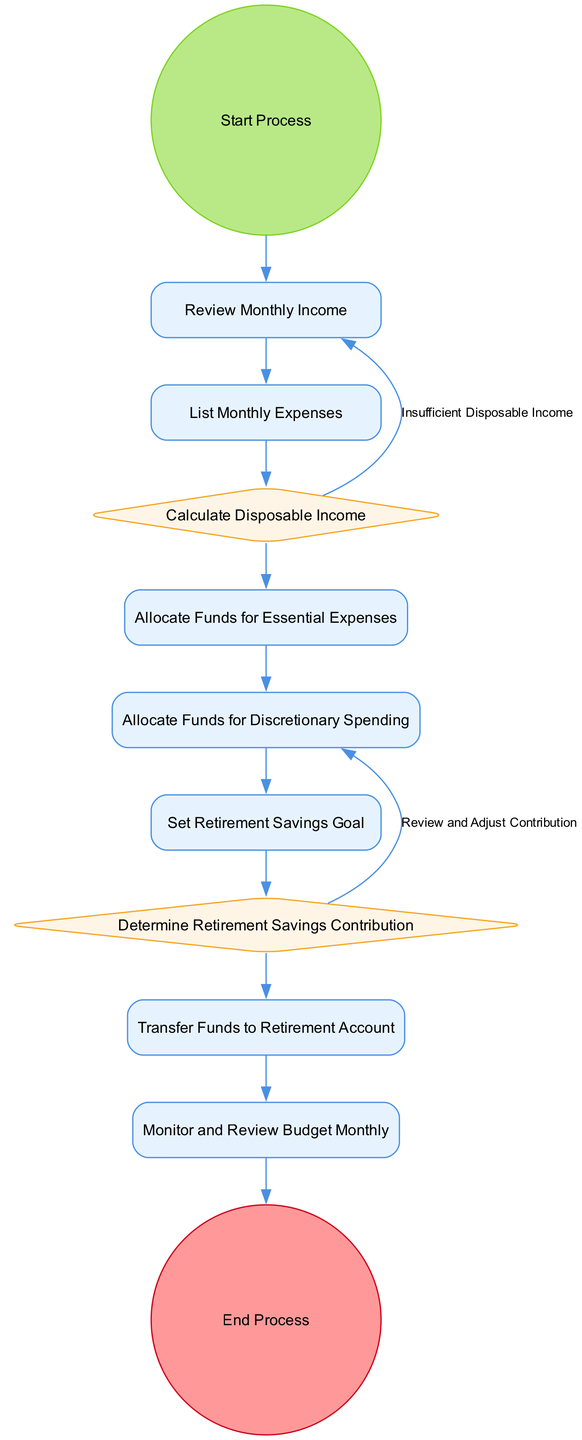What is the first activity in the diagram? The first activity listed in the diagram is "Start Process," which indicates the beginning of the flow.
Answer: Start Process How many actions are present in the diagram? The diagram contains five actions: "Review Monthly Income," "List Monthly Expenses," "Allocate Funds for Essential Expenses," "Allocate Funds for Discretionary Spending," and "Transfer Funds to Retirement Account," totaling five actions.
Answer: Five What are the outcomes of the decision node "Calculate Disposable Income"? The "Calculate Disposable Income" node has two outcomes: "Sufficient Disposable Income" and "Insufficient Disposable Income," representing two possible paths depending on the user's income analysis.
Answer: Sufficient Disposable Income, Insufficient Disposable Income Which activity follows "Set Retirement Savings Goal"? The activity that follows "Set Retirement Savings Goal" is "Determine Retirement Savings Contribution," showing that defining goals precedes evaluating how much to contribute to savings.
Answer: Determine Retirement Savings Contribution What decision is made after determining retirement savings contribution? After determining retirement savings contribution, there is a decision point labeled "Determine Retirement Savings Contribution" with two outcomes: "Adequate Contribution" and "Review and Adjust Contribution," indicating a check on the sufficiency of the contribution.
Answer: Adequate Contribution, Review and Adjust Contribution What is the last activity before ending the process? The last activity before ending the process is "Monitor and Review Budget Monthly," which signifies ongoing financial management before completing the budgeting cycle.
Answer: Monitor and Review Budget Monthly How do you transfer funds to the retirement account? You transfer funds to the retirement account by completing the activity "Transfer Funds to Retirement Account," which is the step taken when sufficient disposable income and contribution are established.
Answer: Transfer Funds to Retirement Account What type of diagram is this? The diagram is an "Activity Diagram," which illustrates the flow of actions and decisions involved in managing monthly budget allocation for retirement savings.
Answer: Activity Diagram How many decision nodes are there in the diagram? There are two decision nodes in the diagram: "Calculate Disposable Income" and "Determine Retirement Savings Contribution," highlighting points where evaluations occur.
Answer: Two 